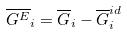<formula> <loc_0><loc_0><loc_500><loc_500>\overline { G ^ { E } } _ { i } = \overline { G } _ { i } - \overline { G } _ { i } ^ { i d }</formula> 